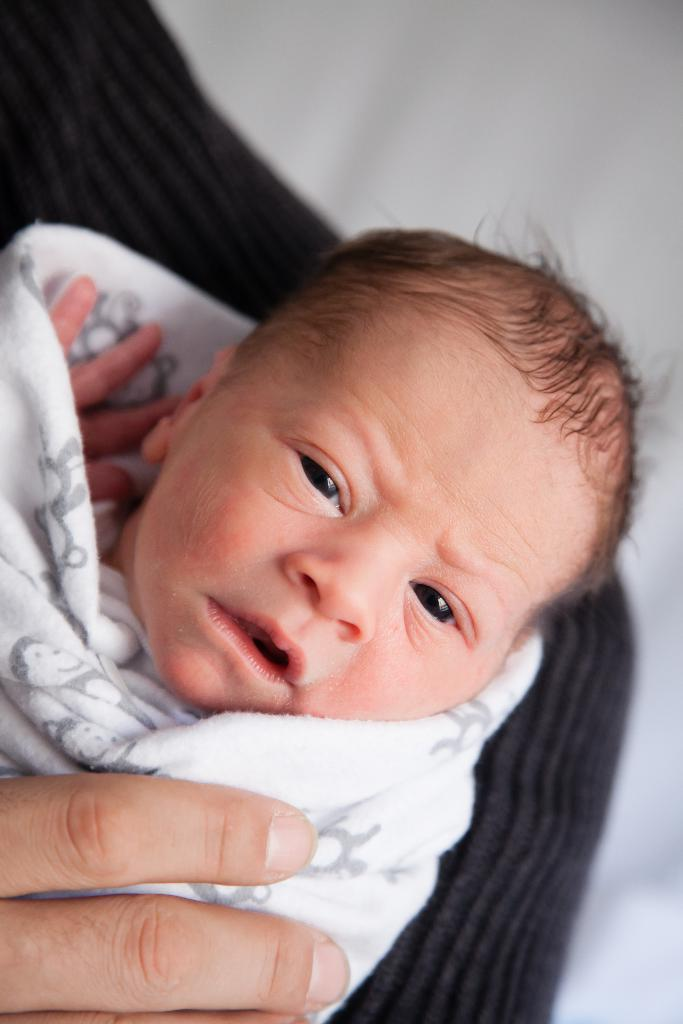What is the main subject of the image? There is a baby in the image. What is the baby's current situation in the image? The baby is being held by a person. What type of glue is being used to connect the baby to the person in the image? There is no glue or connection being made in the image; the baby is simply being held by a person. What kind of nut is visible in the image? There are no nuts present in the image. 